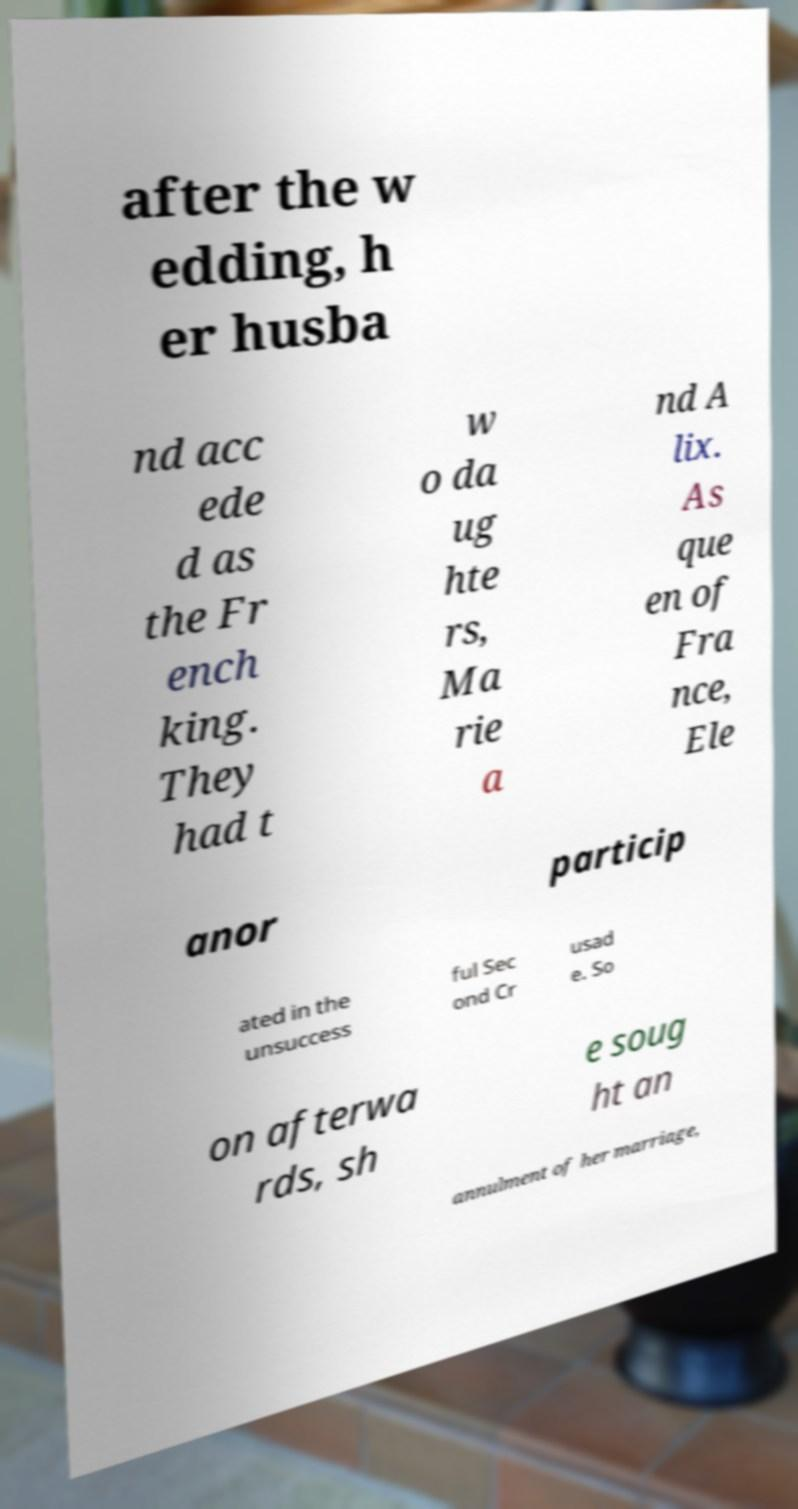Could you extract and type out the text from this image? after the w edding, h er husba nd acc ede d as the Fr ench king. They had t w o da ug hte rs, Ma rie a nd A lix. As que en of Fra nce, Ele anor particip ated in the unsuccess ful Sec ond Cr usad e. So on afterwa rds, sh e soug ht an annulment of her marriage, 